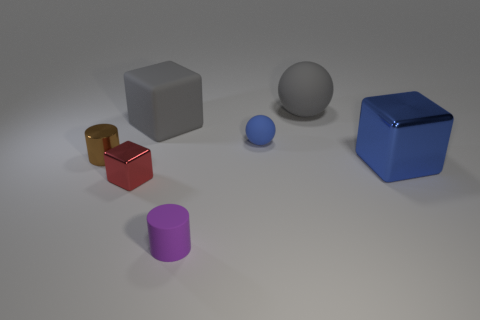Add 1 small blue rubber objects. How many objects exist? 8 Subtract all balls. How many objects are left? 5 Subtract 0 yellow blocks. How many objects are left? 7 Subtract all purple objects. Subtract all big purple metal objects. How many objects are left? 6 Add 6 big rubber things. How many big rubber things are left? 8 Add 5 brown shiny things. How many brown shiny things exist? 6 